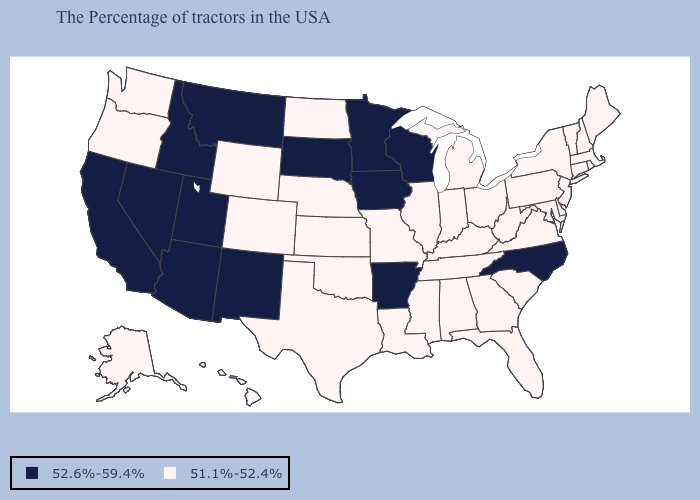Does Mississippi have the lowest value in the USA?
Answer briefly. Yes. Which states have the lowest value in the MidWest?
Short answer required. Ohio, Michigan, Indiana, Illinois, Missouri, Kansas, Nebraska, North Dakota. Which states have the lowest value in the USA?
Short answer required. Maine, Massachusetts, Rhode Island, New Hampshire, Vermont, Connecticut, New York, New Jersey, Delaware, Maryland, Pennsylvania, Virginia, South Carolina, West Virginia, Ohio, Florida, Georgia, Michigan, Kentucky, Indiana, Alabama, Tennessee, Illinois, Mississippi, Louisiana, Missouri, Kansas, Nebraska, Oklahoma, Texas, North Dakota, Wyoming, Colorado, Washington, Oregon, Alaska, Hawaii. What is the highest value in the USA?
Be succinct. 52.6%-59.4%. Does the first symbol in the legend represent the smallest category?
Be succinct. No. Does Delaware have the same value as Kansas?
Be succinct. Yes. Name the states that have a value in the range 52.6%-59.4%?
Write a very short answer. North Carolina, Wisconsin, Arkansas, Minnesota, Iowa, South Dakota, New Mexico, Utah, Montana, Arizona, Idaho, Nevada, California. What is the highest value in the USA?
Concise answer only. 52.6%-59.4%. Does the first symbol in the legend represent the smallest category?
Short answer required. No. What is the value of Florida?
Be succinct. 51.1%-52.4%. Does Hawaii have the highest value in the West?
Keep it brief. No. How many symbols are there in the legend?
Quick response, please. 2. What is the value of Oregon?
Write a very short answer. 51.1%-52.4%. What is the value of Missouri?
Be succinct. 51.1%-52.4%. 